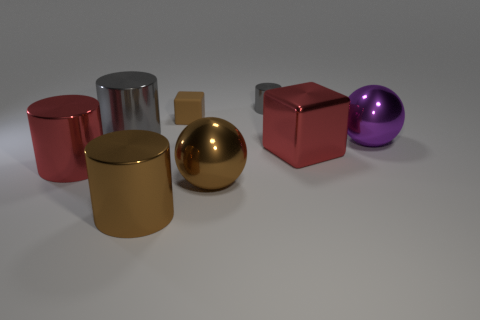Is there a tiny cube that has the same material as the small gray cylinder?
Provide a short and direct response. No. How many shiny things are in front of the tiny cube and behind the big brown cylinder?
Offer a terse response. 5. Are there fewer spheres behind the small block than tiny gray cylinders left of the large gray metallic cylinder?
Make the answer very short. No. Do the large purple shiny object and the small brown matte object have the same shape?
Your response must be concise. No. How many other objects are the same size as the brown block?
Your response must be concise. 1. How many things are large brown shiny objects that are left of the brown matte thing or large metal things behind the red metal cylinder?
Offer a very short reply. 4. How many red metallic things have the same shape as the big purple object?
Keep it short and to the point. 0. The big thing that is behind the large shiny block and left of the red block is made of what material?
Your answer should be compact. Metal. There is a big cube; what number of large red metal things are to the right of it?
Make the answer very short. 0. What number of big brown cylinders are there?
Keep it short and to the point. 1. 